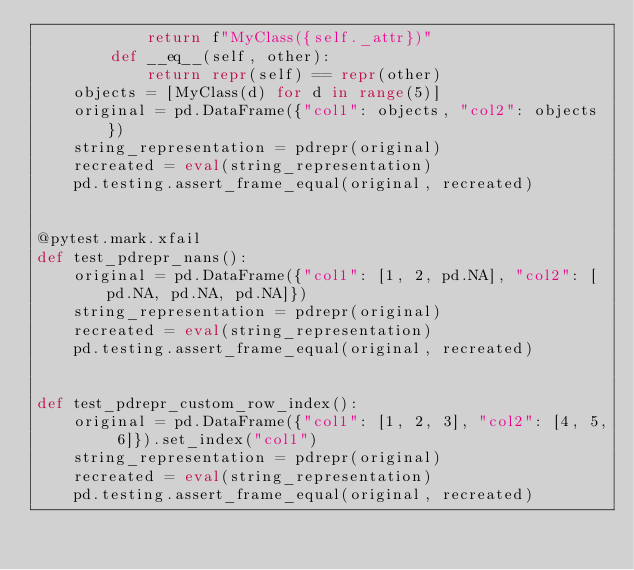<code> <loc_0><loc_0><loc_500><loc_500><_Python_>            return f"MyClass({self._attr})"
        def __eq__(self, other):
            return repr(self) == repr(other)
    objects = [MyClass(d) for d in range(5)]
    original = pd.DataFrame({"col1": objects, "col2": objects})
    string_representation = pdrepr(original)
    recreated = eval(string_representation)
    pd.testing.assert_frame_equal(original, recreated)


@pytest.mark.xfail
def test_pdrepr_nans():
    original = pd.DataFrame({"col1": [1, 2, pd.NA], "col2": [pd.NA, pd.NA, pd.NA]})
    string_representation = pdrepr(original)
    recreated = eval(string_representation)
    pd.testing.assert_frame_equal(original, recreated)


def test_pdrepr_custom_row_index():
    original = pd.DataFrame({"col1": [1, 2, 3], "col2": [4, 5, 6]}).set_index("col1")
    string_representation = pdrepr(original)
    recreated = eval(string_representation)
    pd.testing.assert_frame_equal(original, recreated)

</code> 